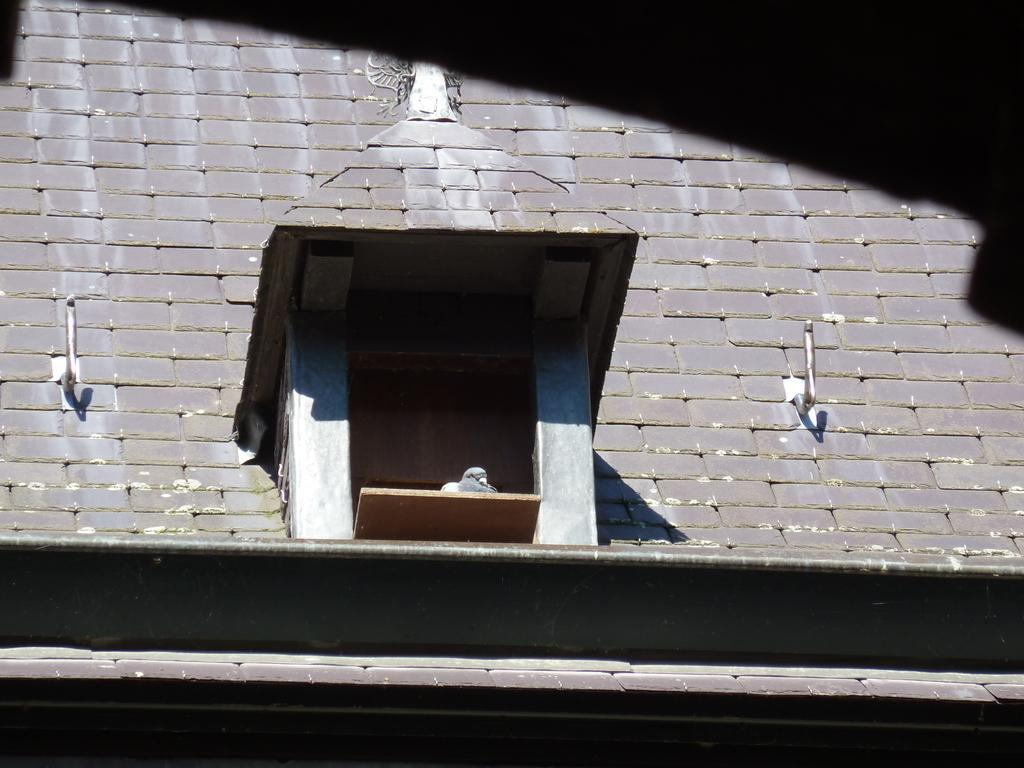What is the main subject in the center of the image? There is a building in the center of the image. Can you describe any additional details about the building? There is a bird sitting on the shelf of the building. What degree does the bird have in the image? There is no indication of the bird having a degree in the image. How much sugar is in the bird's nest in the image? There is no bird's nest or sugar present in the image. 